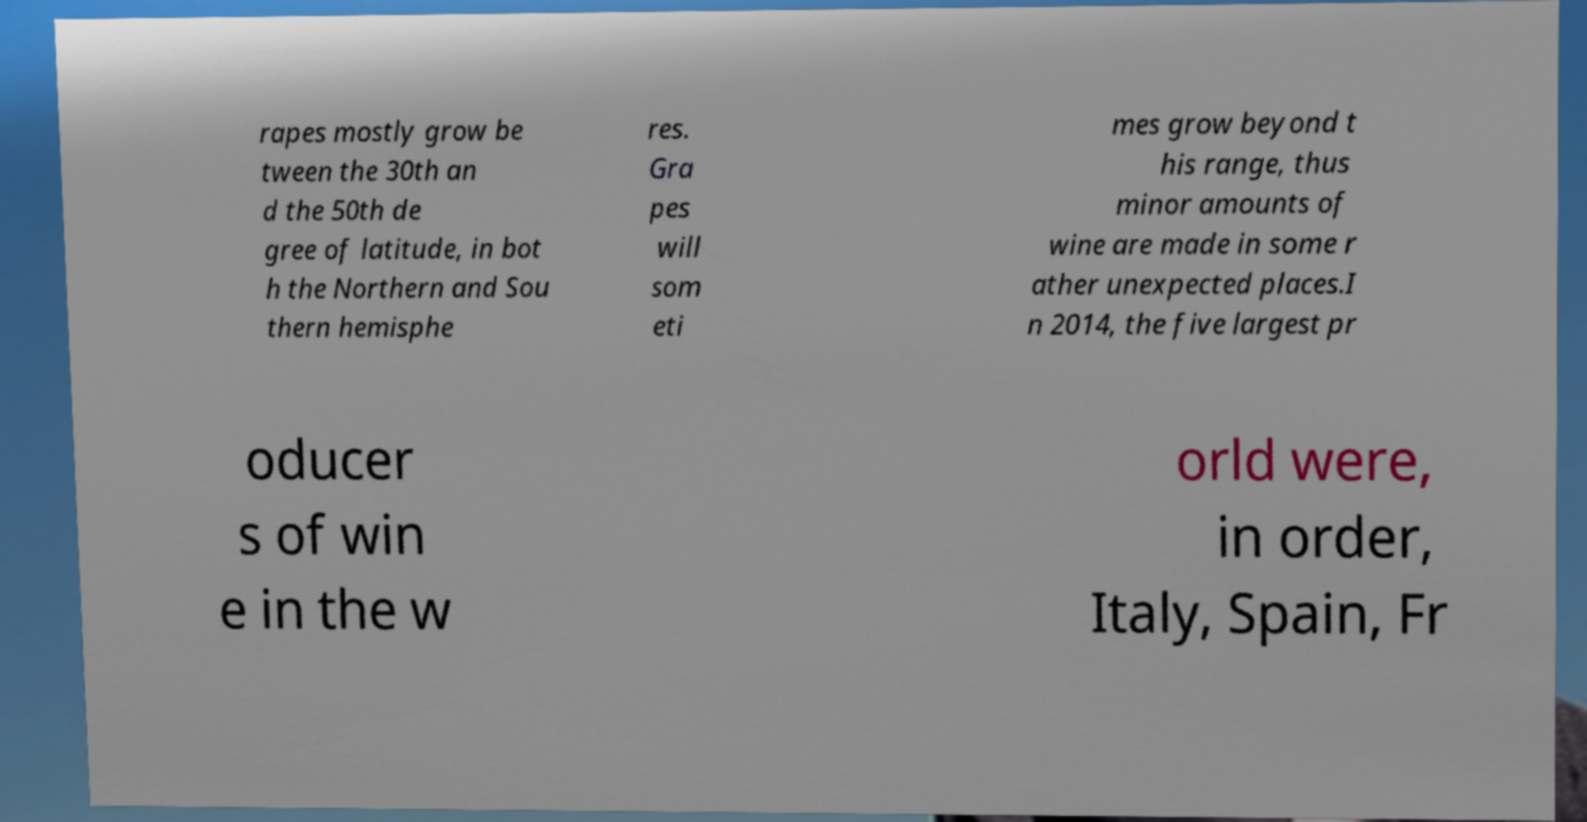For documentation purposes, I need the text within this image transcribed. Could you provide that? rapes mostly grow be tween the 30th an d the 50th de gree of latitude, in bot h the Northern and Sou thern hemisphe res. Gra pes will som eti mes grow beyond t his range, thus minor amounts of wine are made in some r ather unexpected places.I n 2014, the five largest pr oducer s of win e in the w orld were, in order, Italy, Spain, Fr 